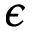<formula> <loc_0><loc_0><loc_500><loc_500>\epsilon</formula> 